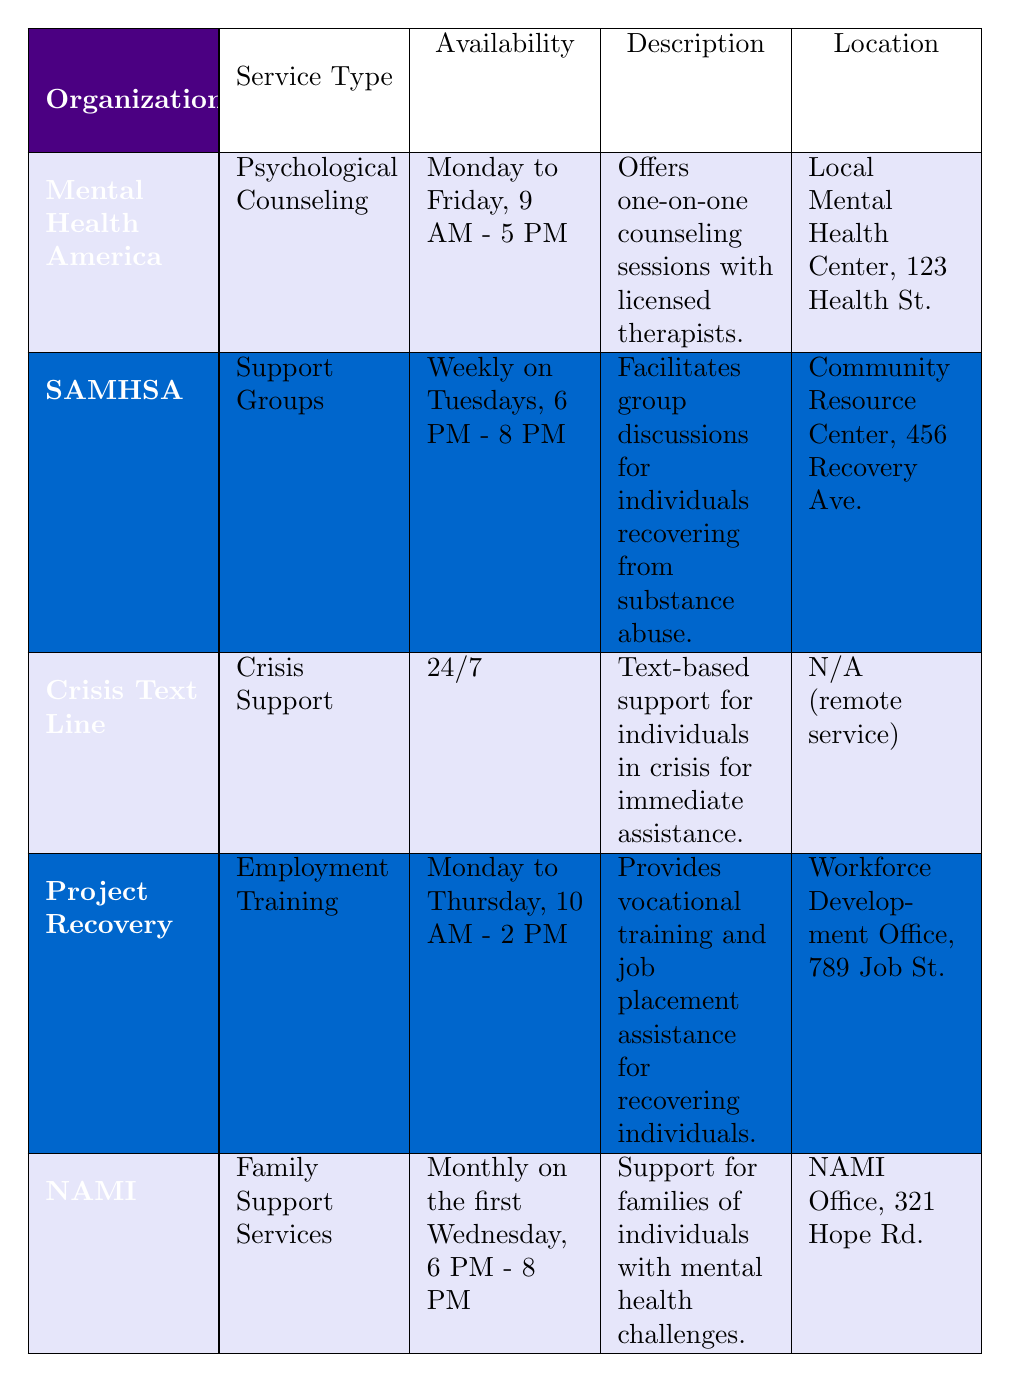What services does Mental Health America provide? According to the table, Mental Health America provides "Psychological Counseling."
Answer: Psychological Counseling When is the support group session held by SAMHSA? The availability for the SAMHSA support group is "Weekly on Tuesdays, 6 PM - 8 PM."
Answer: Weekly on Tuesdays, 6 PM - 8 PM Is Crisis Text Line available for support during the night? The table states that Crisis Text Line offers support "24/7," indicating it is available at night and all times.
Answer: Yes How often does NAMI offer Family Support Services? The table indicates that NAMI offers its Family Support Services "Monthly on the first Wednesday, 6 PM - 8 PM," which means it is provided once a month.
Answer: Monthly Which organization provides employment training? The table lists "Project Recovery" as the organization that provides "Employment Training."
Answer: Project Recovery How many support services are provided from Monday to Friday? From the table, the organizations offering services Monday to Friday are Mental Health America (Psychological Counseling) and Project Recovery (which is Monday to Thursday), totaling two services provided on weekdays.
Answer: 2 Is there any organization that offers crisis support? According to the table, the "Crisis Text Line" offers "Crisis Support." Hence, the answer to the question is yes.
Answer: Yes What types of services are provided by NAMI and who are they for? The table indicates that NAMI provides "Family Support Services" which is support specifically for families of individuals with mental health challenges, fulfilling this requirement.
Answer: Family Support Services for families What is the location of Project Recovery? The table states that Project Recovery is located at "Workforce Development Office, 789 Job St."
Answer: Workforce Development Office, 789 Job St 